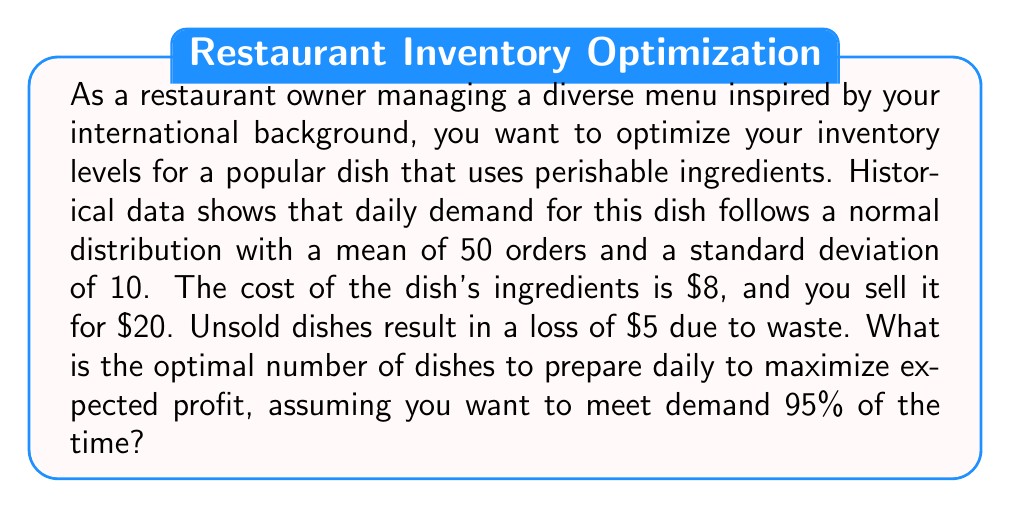Show me your answer to this math problem. To solve this problem, we'll use the newsvendor model from inventory management theory. The steps are:

1) First, we need to find the critical fractile (CF), which is given by:

   $$ CF = \frac{p - c}{p - s} $$

   Where:
   $p$ = selling price = $20
   $c$ = cost price = $8
   $s$ = salvage value = $-5$ (loss due to waste)

   $$ CF = \frac{20 - 8}{20 - (-5)} = \frac{12}{25} = 0.48 $$

2) We want to meet demand 95% of the time, which corresponds to the 95th percentile of the normal distribution. This is higher than our critical fractile, so we'll use 0.95 instead of 0.48.

3) For a normal distribution, the 95th percentile is approximately 1.645 standard deviations above the mean. We can calculate the optimal quantity $Q^*$ as:

   $$ Q^* = \mu + z\sigma $$

   Where:
   $\mu$ = mean demand = 50
   $\sigma$ = standard deviation of demand = 10
   $z$ = number of standard deviations (1.645 for 95th percentile)

4) Plugging in the values:

   $$ Q^* = 50 + 1.645 * 10 = 66.45 $$

5) Since we can't prepare a fractional number of dishes, we round up to the nearest integer.
Answer: The optimal number of dishes to prepare daily is 67. 